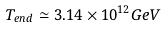Convert formula to latex. <formula><loc_0><loc_0><loc_500><loc_500>T _ { e n d } \simeq 3 . 1 4 \times 1 0 ^ { 1 2 } G e V</formula> 